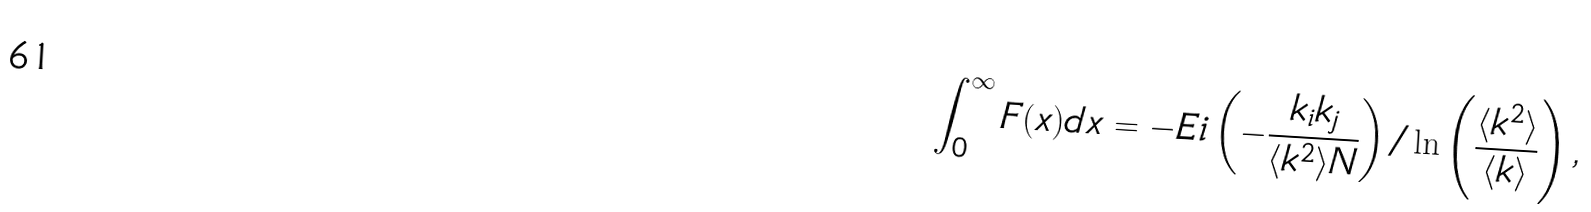Convert formula to latex. <formula><loc_0><loc_0><loc_500><loc_500>\int _ { 0 } ^ { \infty } F ( x ) d x = - E i \left ( - \frac { k _ { i } k _ { j } } { \langle k ^ { 2 } \rangle N } \right ) / \ln \left ( \frac { \langle k ^ { 2 } \rangle } { \langle k \rangle } \right ) ,</formula> 